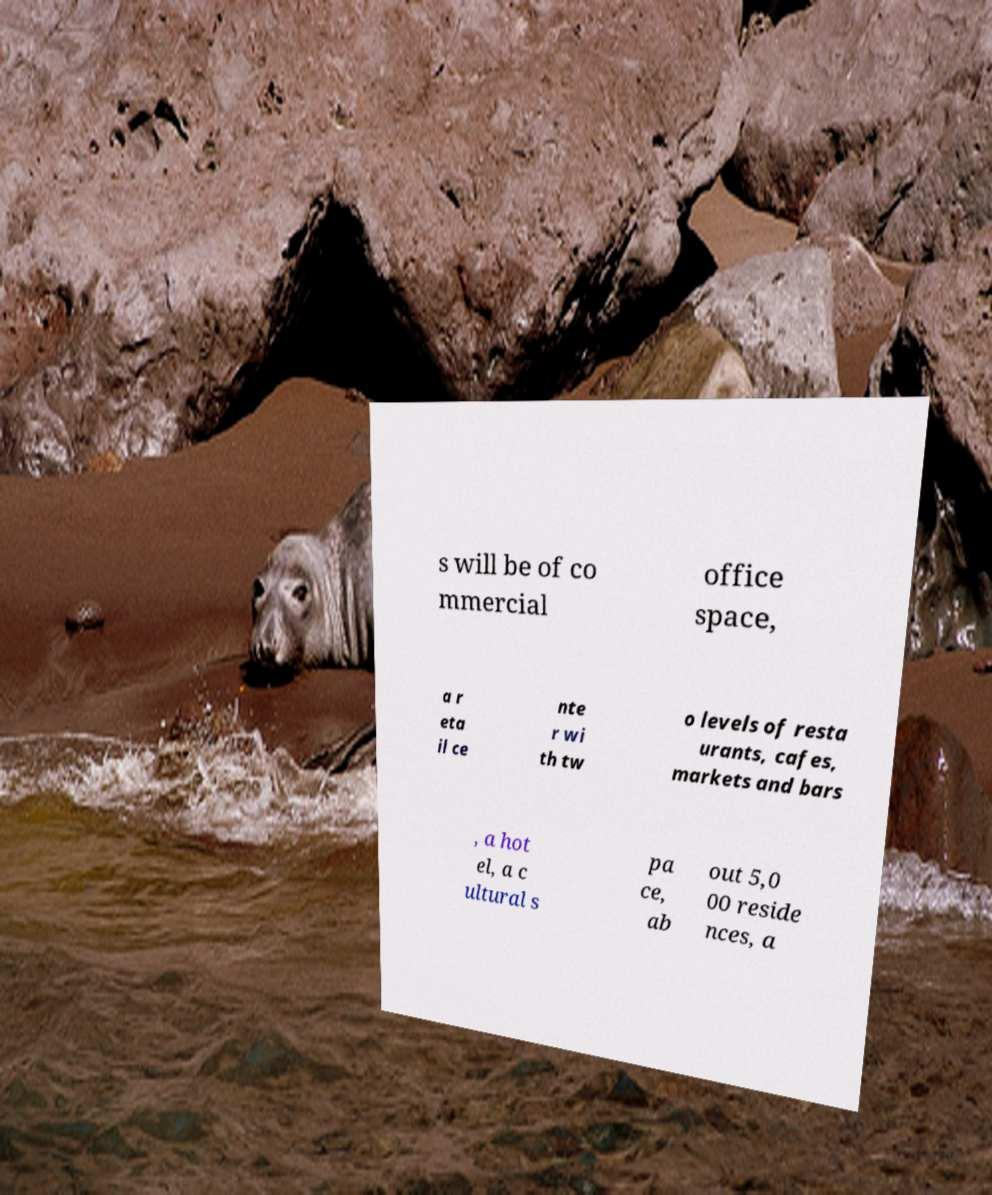Please identify and transcribe the text found in this image. s will be of co mmercial office space, a r eta il ce nte r wi th tw o levels of resta urants, cafes, markets and bars , a hot el, a c ultural s pa ce, ab out 5,0 00 reside nces, a 